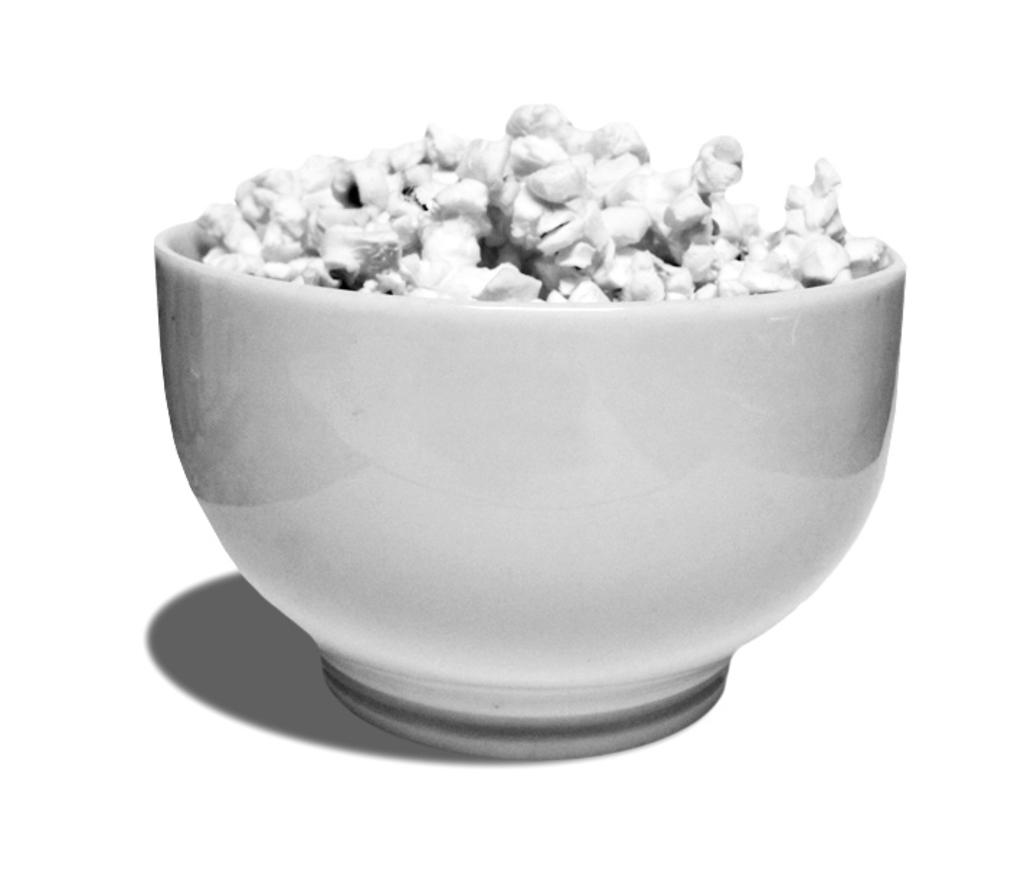What color is the bowl in the image? The bowl in the image is white. What is inside the bowl? There is food in the bowl. How does the sun feel about the food in the bowl? The sun is not a sentient being and therefore cannot have feelings or opinions about the food in the bowl. 